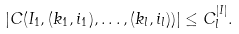<formula> <loc_0><loc_0><loc_500><loc_500>| C ( I _ { 1 } , ( k _ { 1 } , i _ { 1 } ) , \dots , ( k _ { l } , i _ { l } ) ) | \leq C _ { l } ^ { | I | } .</formula> 